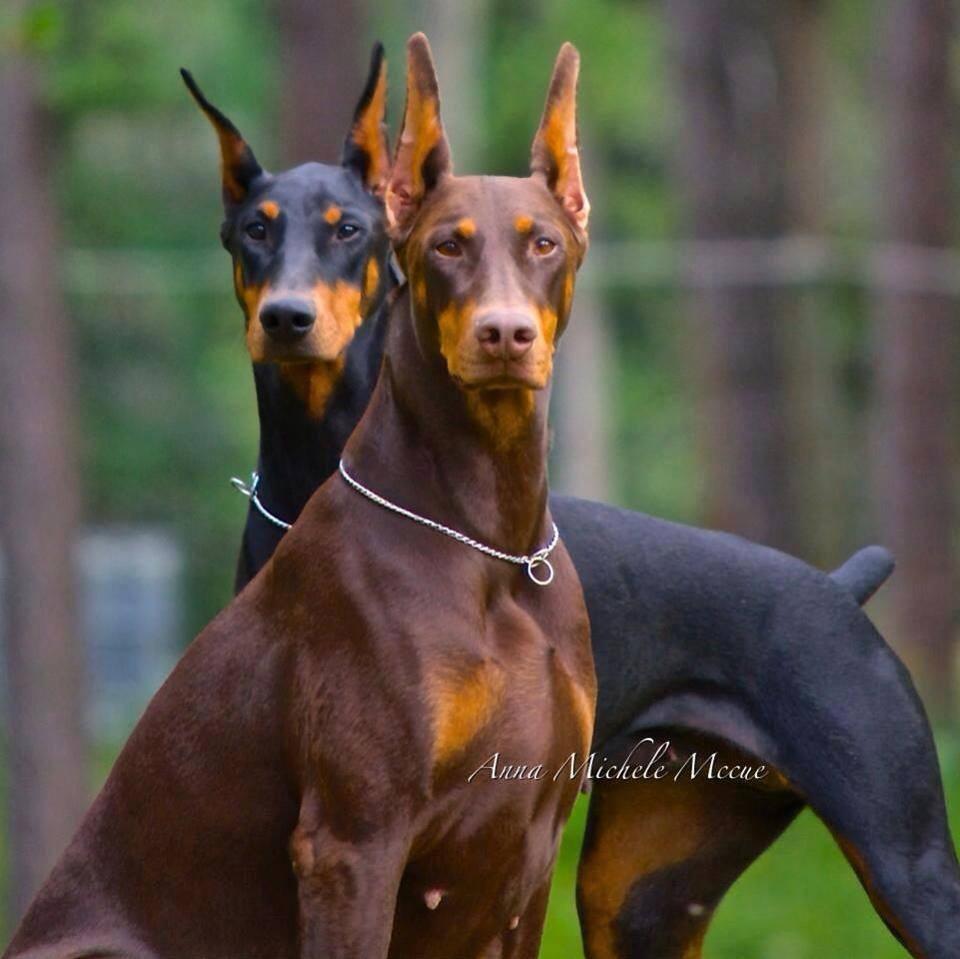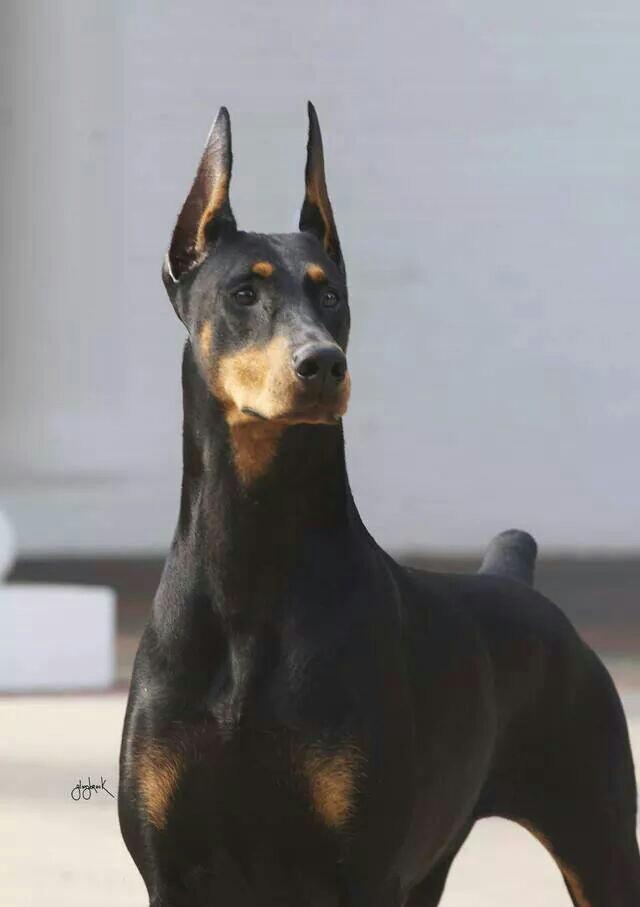The first image is the image on the left, the second image is the image on the right. Examine the images to the left and right. Is the description "There are two dogs, and one of the dogs has cropped ears, while the other dog's ears are uncropped." accurate? Answer yes or no. No. 